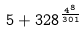Convert formula to latex. <formula><loc_0><loc_0><loc_500><loc_500>5 + 3 2 8 ^ { \frac { 4 ^ { 8 } } { 3 0 1 } }</formula> 